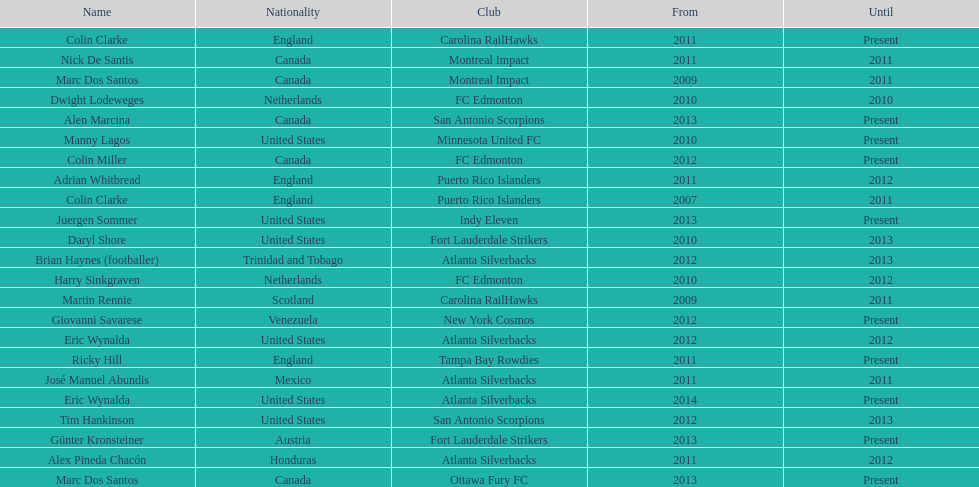How long did colin clarke coach the puerto rico islanders? 4 years. 